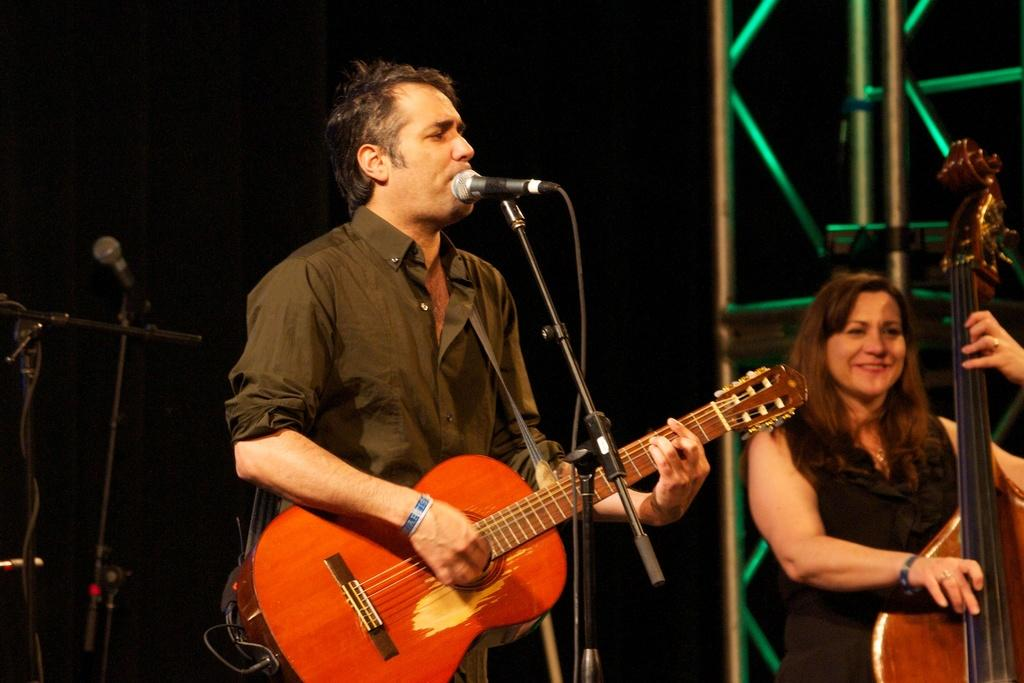Who is the main subject in the image? There is a man in the image. What is the man wearing? The man is wearing a black dress. What is the man doing in the image? The man is playing a guitar. What object is present in the image that is typically used for amplifying sound? There is a microphone in the image. Can you identify another person in the image? Yes, there is a woman in the image. What is the woman doing in the image? The woman is playing a musical instrument. What type of clouds can be seen in the image? There are no clouds present in the image. What time does the clock in the image show? There is no clock present in the image. 